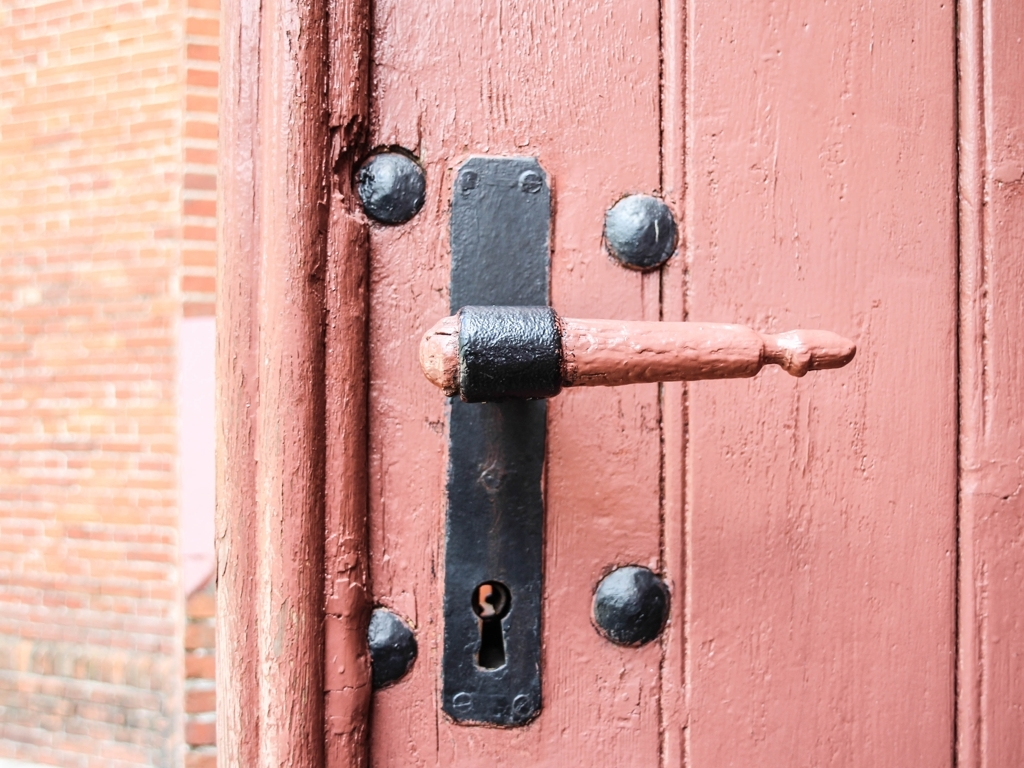What can be inferred about the building's age and use from this door? From the style of the door handle and the wear on the door, one could infer that the building has historical significance and might be used in a context that preserves its original character, such as a heritage site, museum, or traditional residential building. 